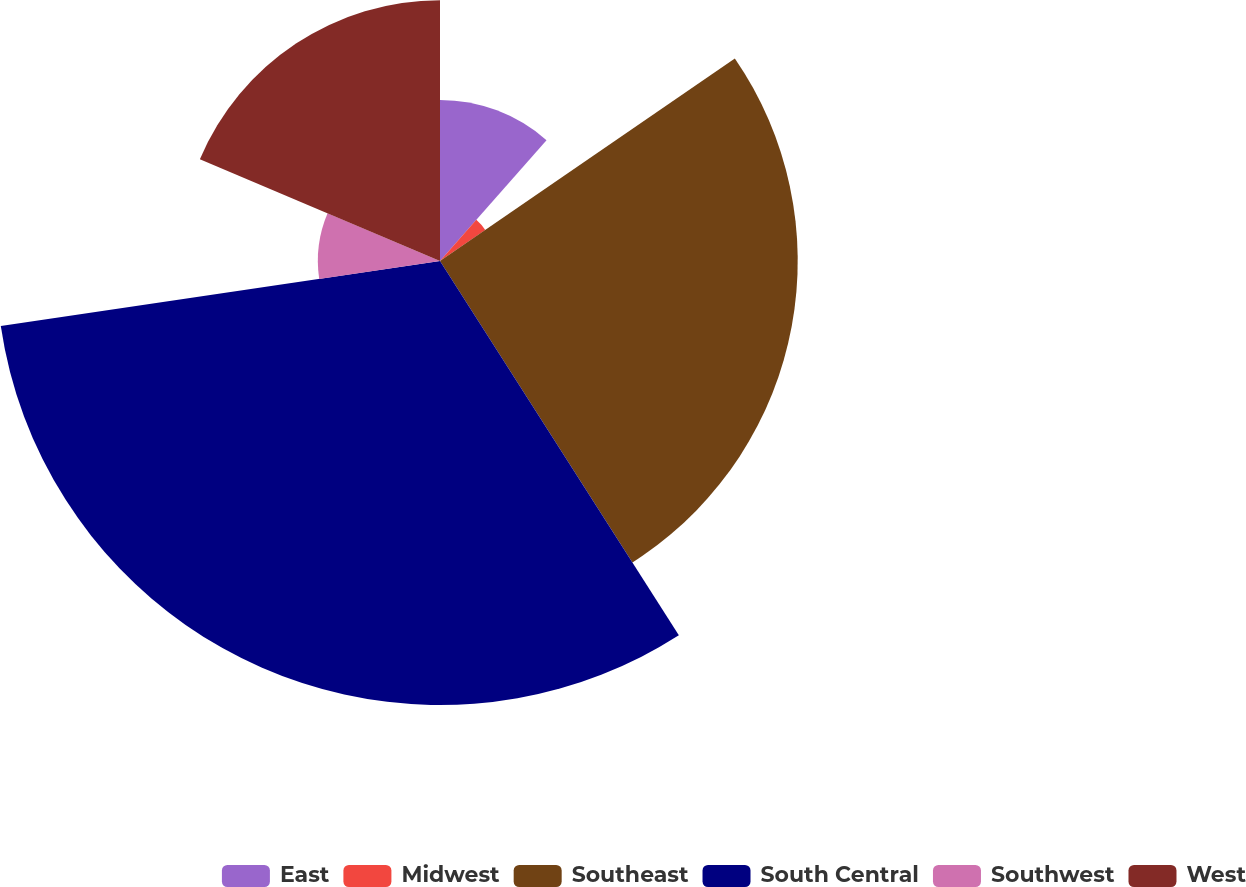Convert chart. <chart><loc_0><loc_0><loc_500><loc_500><pie_chart><fcel>East<fcel>Midwest<fcel>Southeast<fcel>South Central<fcel>Southwest<fcel>West<nl><fcel>11.5%<fcel>3.92%<fcel>25.54%<fcel>31.7%<fcel>8.72%<fcel>18.62%<nl></chart> 